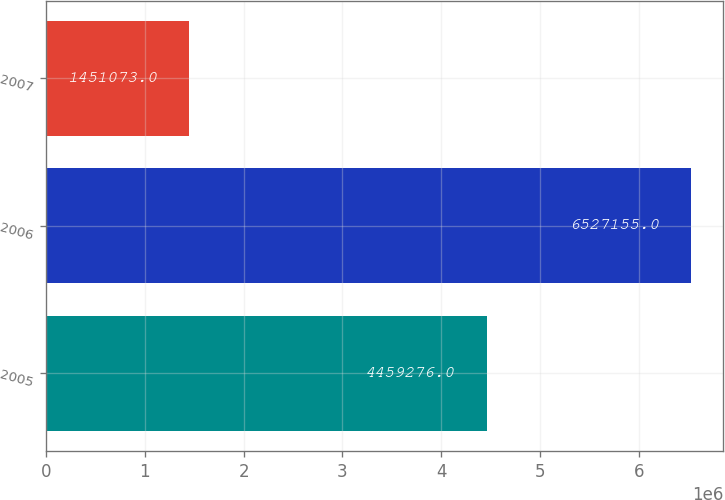Convert chart to OTSL. <chart><loc_0><loc_0><loc_500><loc_500><bar_chart><fcel>2005<fcel>2006<fcel>2007<nl><fcel>4.45928e+06<fcel>6.52716e+06<fcel>1.45107e+06<nl></chart> 